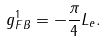<formula> <loc_0><loc_0><loc_500><loc_500>g _ { F B } ^ { 1 } = - \frac { \pi } { 4 } L _ { e } .</formula> 